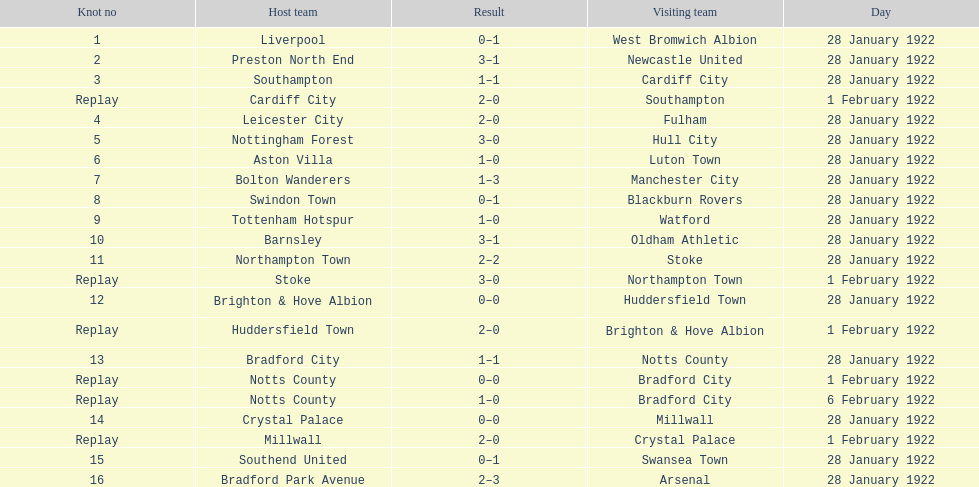How many games had no points scored? 3. 